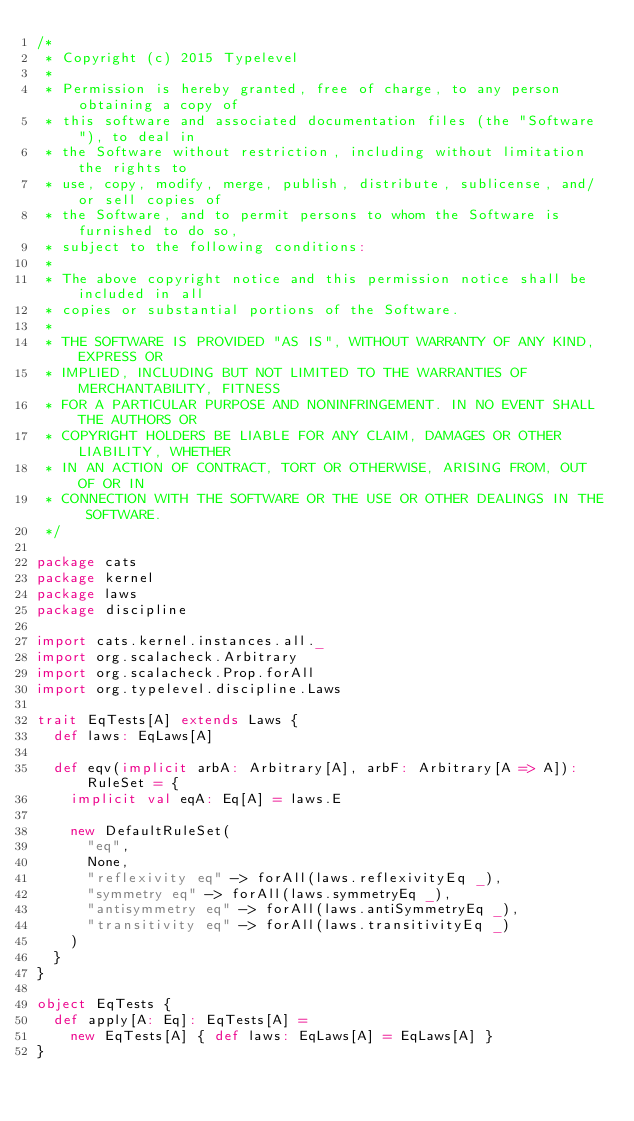<code> <loc_0><loc_0><loc_500><loc_500><_Scala_>/*
 * Copyright (c) 2015 Typelevel
 *
 * Permission is hereby granted, free of charge, to any person obtaining a copy of
 * this software and associated documentation files (the "Software"), to deal in
 * the Software without restriction, including without limitation the rights to
 * use, copy, modify, merge, publish, distribute, sublicense, and/or sell copies of
 * the Software, and to permit persons to whom the Software is furnished to do so,
 * subject to the following conditions:
 *
 * The above copyright notice and this permission notice shall be included in all
 * copies or substantial portions of the Software.
 *
 * THE SOFTWARE IS PROVIDED "AS IS", WITHOUT WARRANTY OF ANY KIND, EXPRESS OR
 * IMPLIED, INCLUDING BUT NOT LIMITED TO THE WARRANTIES OF MERCHANTABILITY, FITNESS
 * FOR A PARTICULAR PURPOSE AND NONINFRINGEMENT. IN NO EVENT SHALL THE AUTHORS OR
 * COPYRIGHT HOLDERS BE LIABLE FOR ANY CLAIM, DAMAGES OR OTHER LIABILITY, WHETHER
 * IN AN ACTION OF CONTRACT, TORT OR OTHERWISE, ARISING FROM, OUT OF OR IN
 * CONNECTION WITH THE SOFTWARE OR THE USE OR OTHER DEALINGS IN THE SOFTWARE.
 */

package cats
package kernel
package laws
package discipline

import cats.kernel.instances.all._
import org.scalacheck.Arbitrary
import org.scalacheck.Prop.forAll
import org.typelevel.discipline.Laws

trait EqTests[A] extends Laws {
  def laws: EqLaws[A]

  def eqv(implicit arbA: Arbitrary[A], arbF: Arbitrary[A => A]): RuleSet = {
    implicit val eqA: Eq[A] = laws.E

    new DefaultRuleSet(
      "eq",
      None,
      "reflexivity eq" -> forAll(laws.reflexivityEq _),
      "symmetry eq" -> forAll(laws.symmetryEq _),
      "antisymmetry eq" -> forAll(laws.antiSymmetryEq _),
      "transitivity eq" -> forAll(laws.transitivityEq _)
    )
  }
}

object EqTests {
  def apply[A: Eq]: EqTests[A] =
    new EqTests[A] { def laws: EqLaws[A] = EqLaws[A] }
}
</code> 